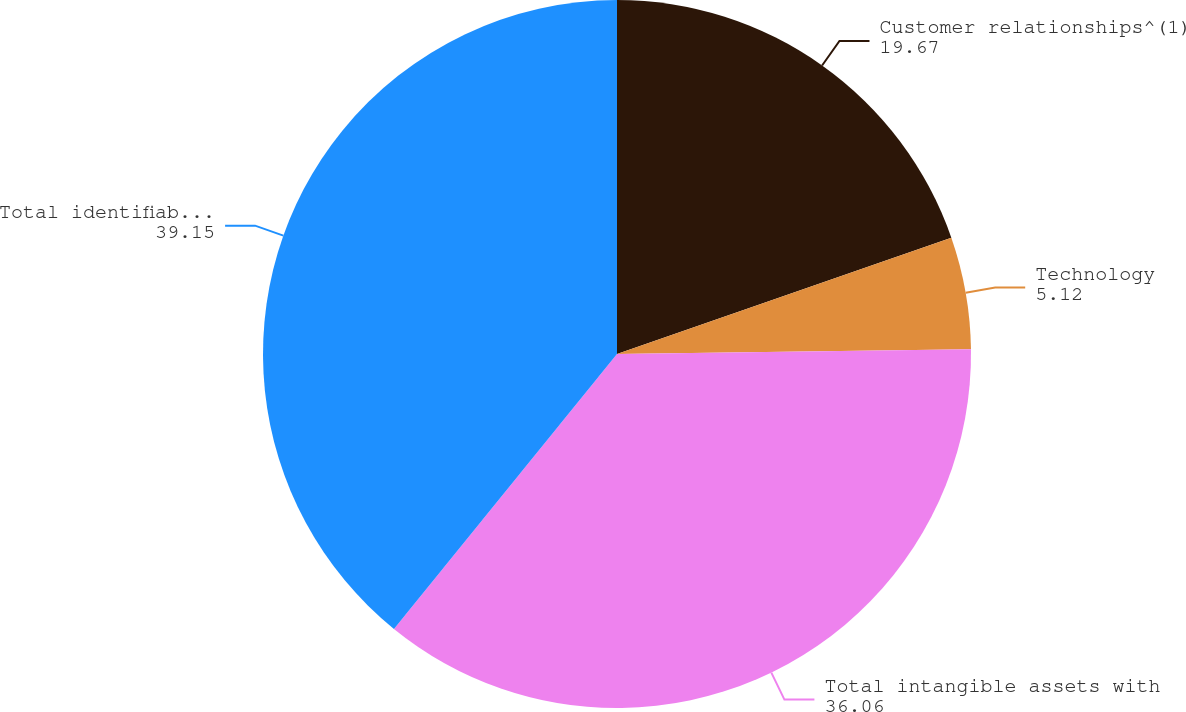<chart> <loc_0><loc_0><loc_500><loc_500><pie_chart><fcel>Customer relationships^(1)<fcel>Technology<fcel>Total intangible assets with<fcel>Total identifiable intangible<nl><fcel>19.67%<fcel>5.12%<fcel>36.06%<fcel>39.15%<nl></chart> 